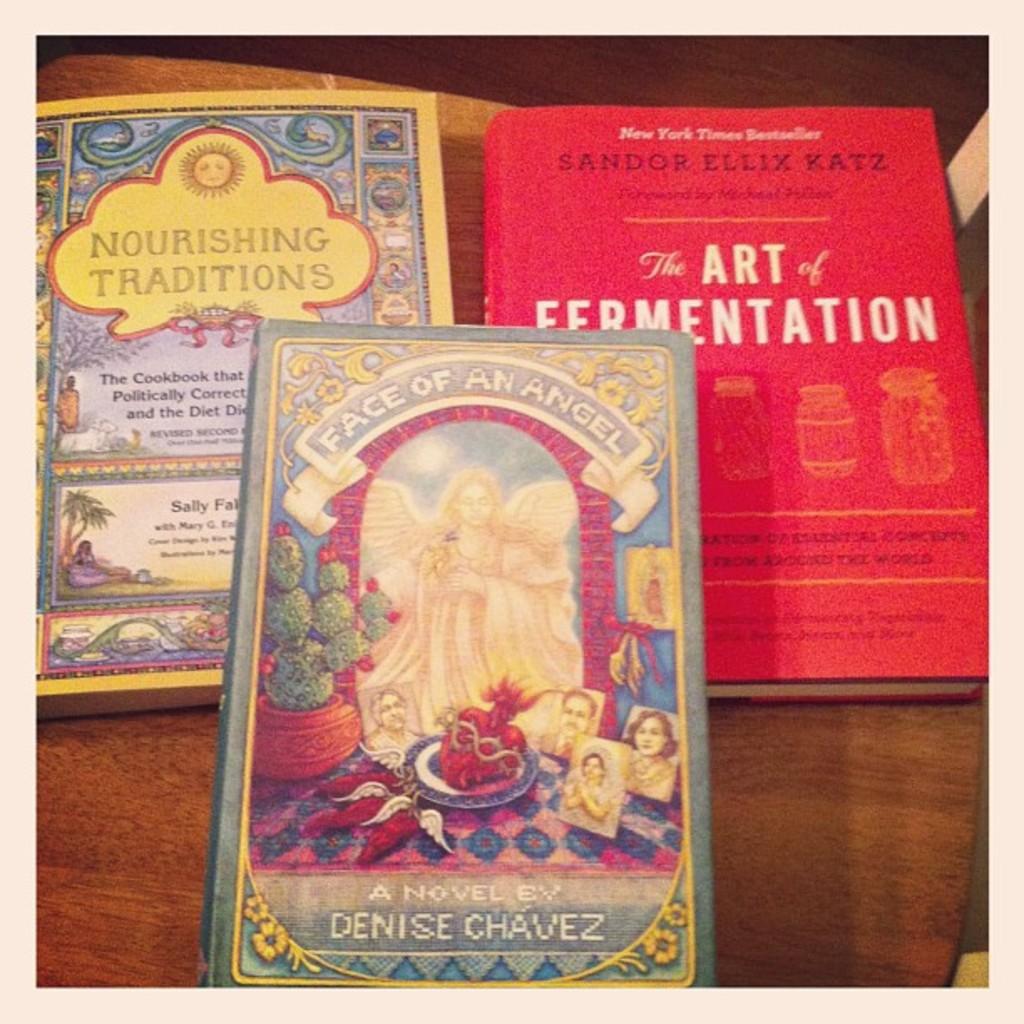Who wrote, "face of an angel"?
Your answer should be very brief. Denise chavez. What does the book to the right say?
Provide a short and direct response. The art of fermentation. 